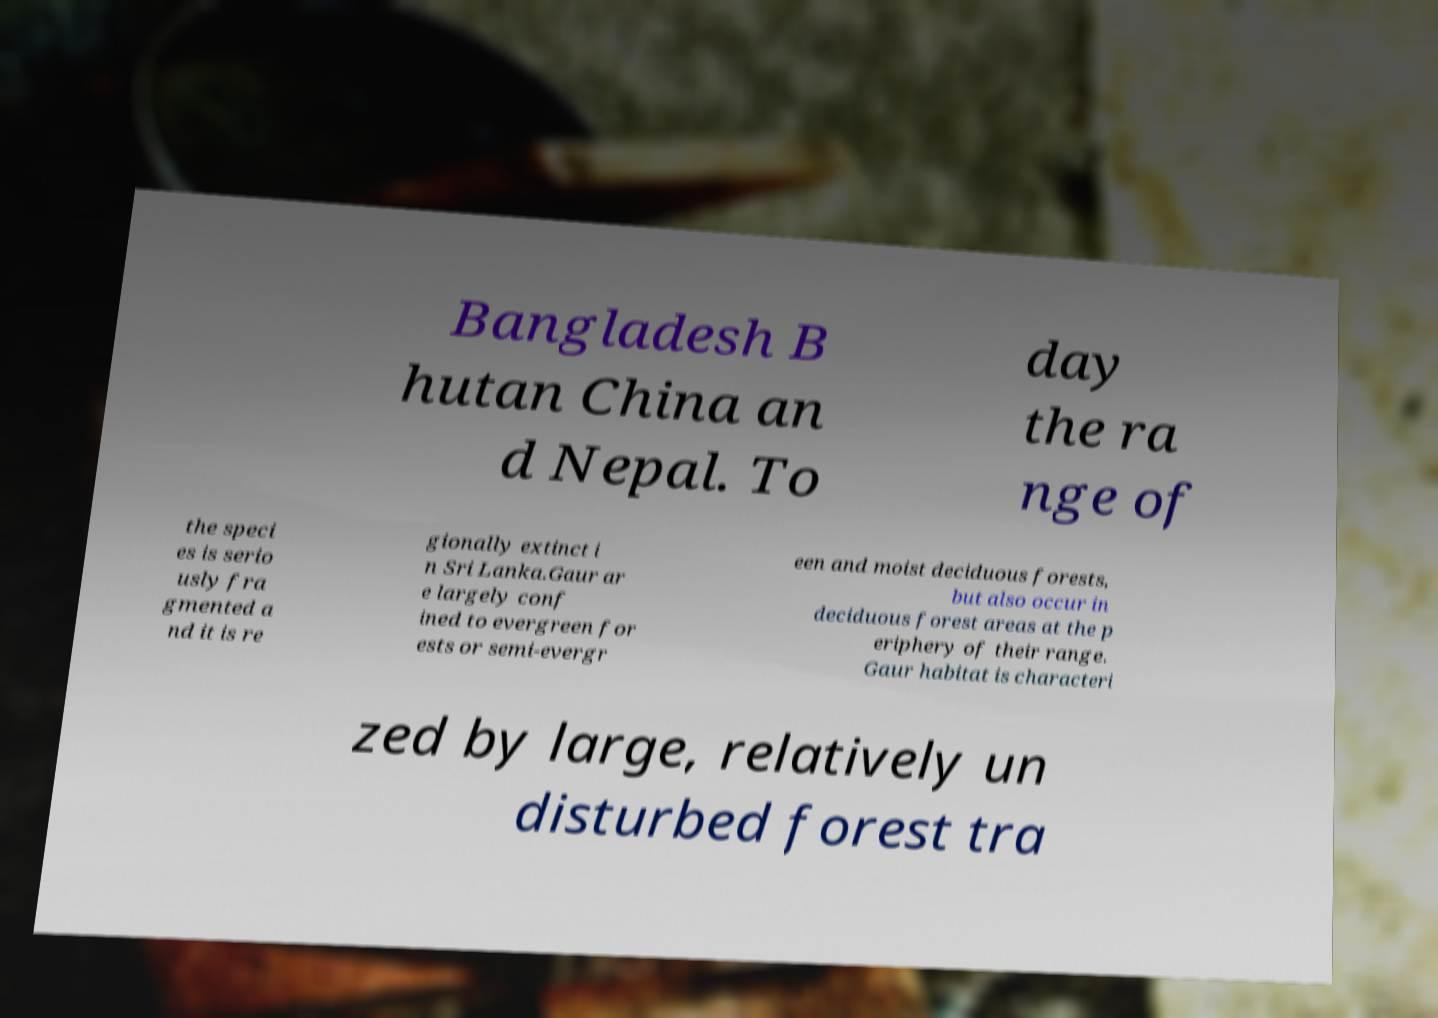What messages or text are displayed in this image? I need them in a readable, typed format. Bangladesh B hutan China an d Nepal. To day the ra nge of the speci es is serio usly fra gmented a nd it is re gionally extinct i n Sri Lanka.Gaur ar e largely conf ined to evergreen for ests or semi-evergr een and moist deciduous forests, but also occur in deciduous forest areas at the p eriphery of their range. Gaur habitat is characteri zed by large, relatively un disturbed forest tra 